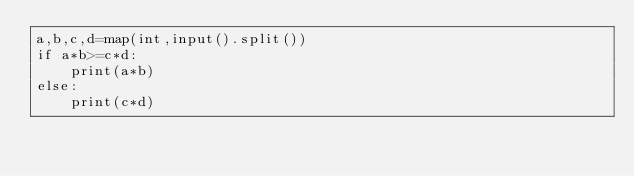<code> <loc_0><loc_0><loc_500><loc_500><_Python_>a,b,c,d=map(int,input().split())
if a*b>=c*d:
    print(a*b)
else:
    print(c*d)</code> 